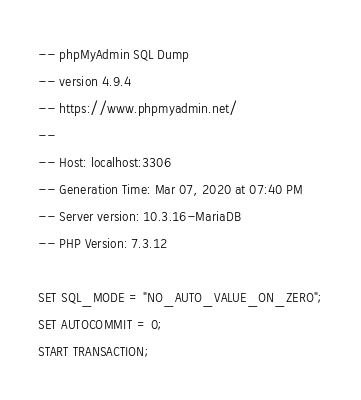Convert code to text. <code><loc_0><loc_0><loc_500><loc_500><_SQL_>-- phpMyAdmin SQL Dump
-- version 4.9.4
-- https://www.phpmyadmin.net/
--
-- Host: localhost:3306
-- Generation Time: Mar 07, 2020 at 07:40 PM
-- Server version: 10.3.16-MariaDB
-- PHP Version: 7.3.12

SET SQL_MODE = "NO_AUTO_VALUE_ON_ZERO";
SET AUTOCOMMIT = 0;
START TRANSACTION;</code> 